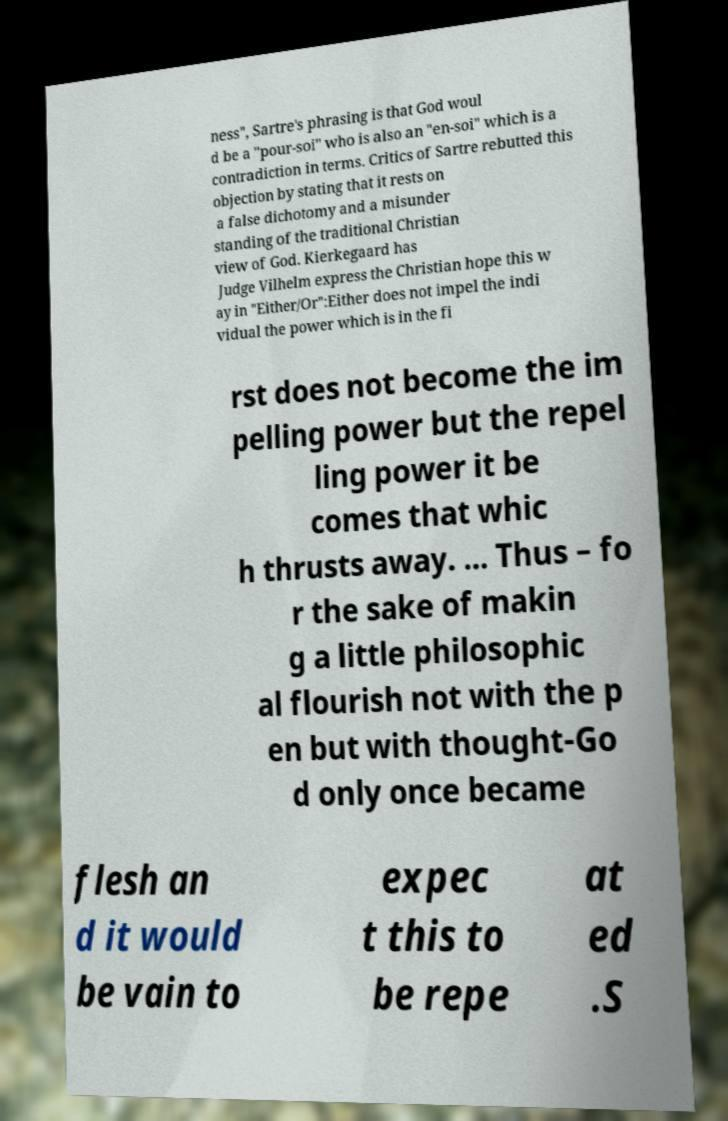Please read and relay the text visible in this image. What does it say? ness", Sartre's phrasing is that God woul d be a "pour-soi" who is also an "en-soi" which is a contradiction in terms. Critics of Sartre rebutted this objection by stating that it rests on a false dichotomy and a misunder standing of the traditional Christian view of God. Kierkegaard has Judge Vilhelm express the Christian hope this w ay in "Either/Or":Either does not impel the indi vidual the power which is in the fi rst does not become the im pelling power but the repel ling power it be comes that whic h thrusts away. ... Thus – fo r the sake of makin g a little philosophic al flourish not with the p en but with thought-Go d only once became flesh an d it would be vain to expec t this to be repe at ed .S 